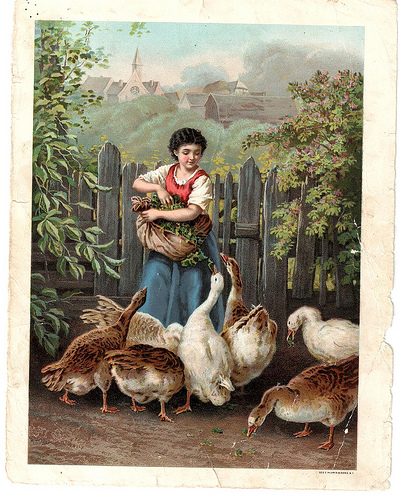<image>
Can you confirm if the girl is behind the fence? No. The girl is not behind the fence. From this viewpoint, the girl appears to be positioned elsewhere in the scene. Is the fence in front of the goose? Yes. The fence is positioned in front of the goose, appearing closer to the camera viewpoint. 